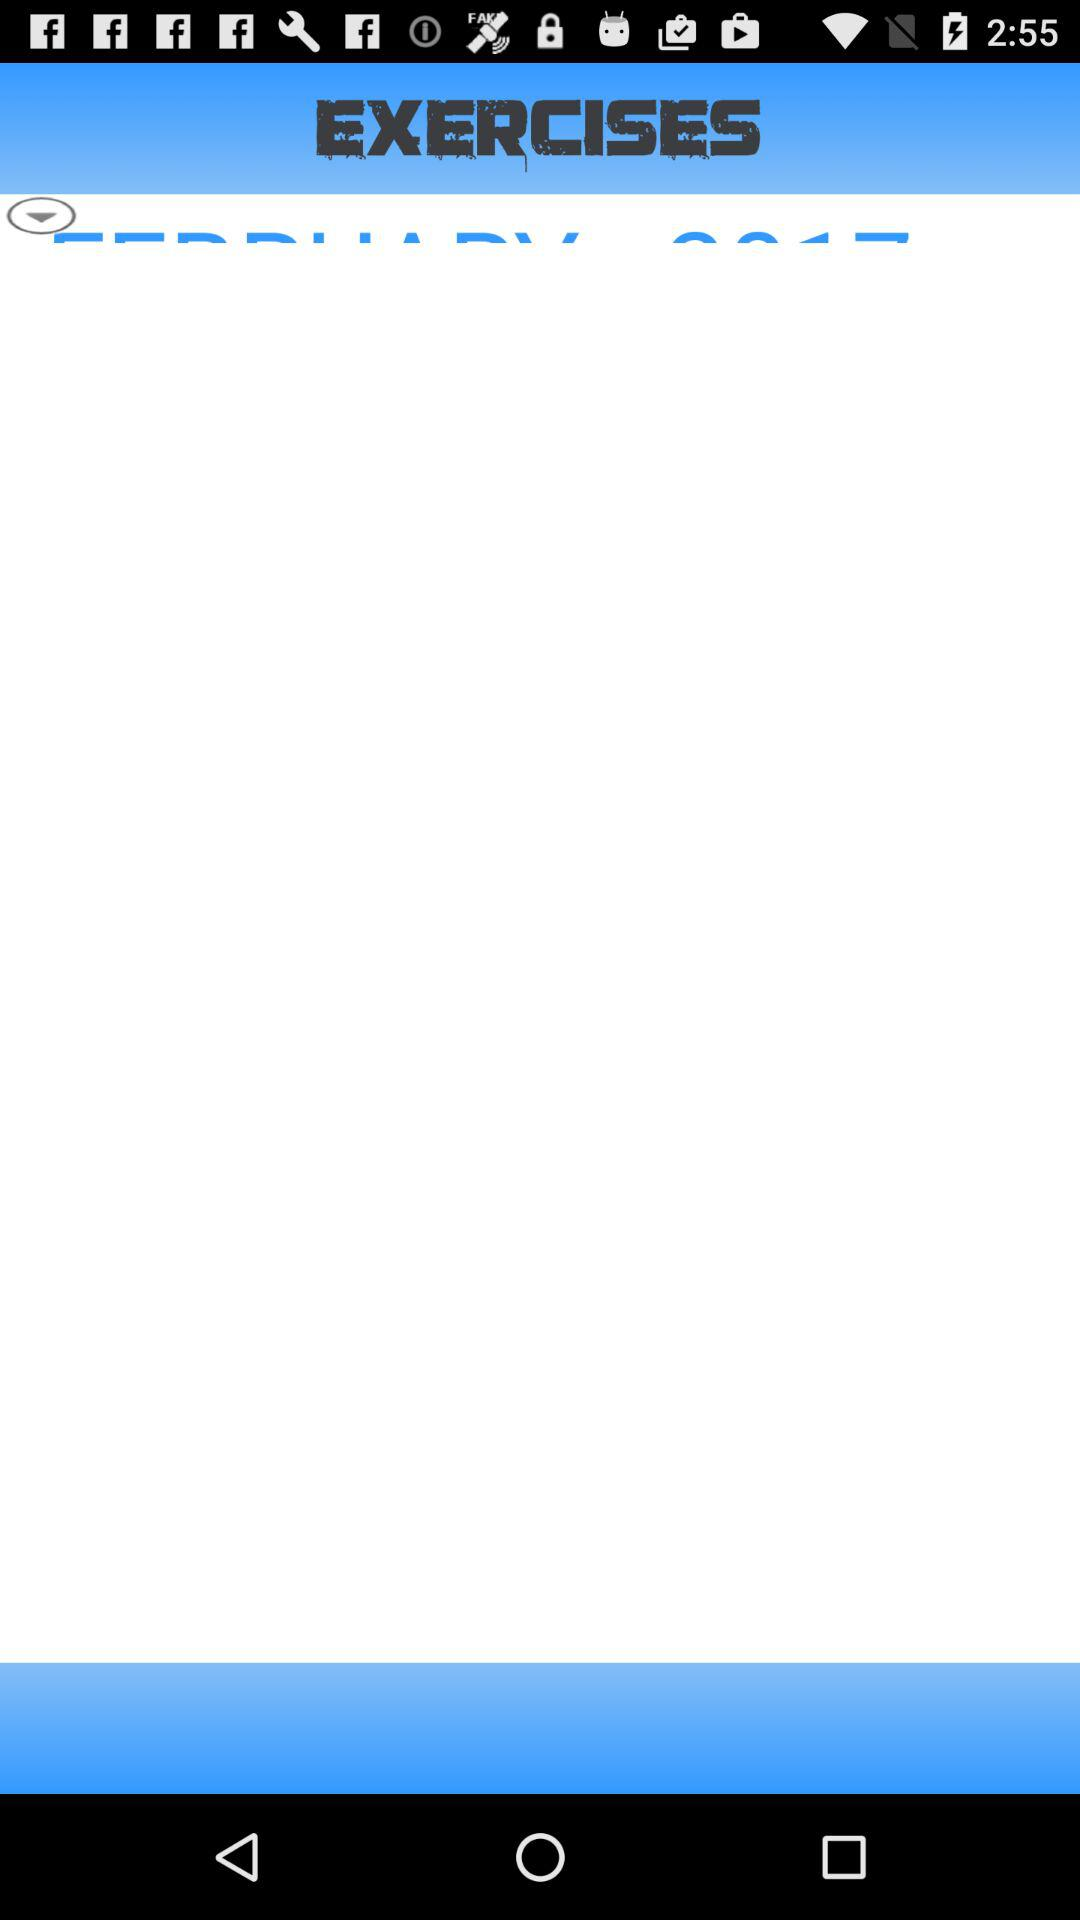How many exercises work out the abdominal muscles?
When the provided information is insufficient, respond with <no answer>. <no answer> 